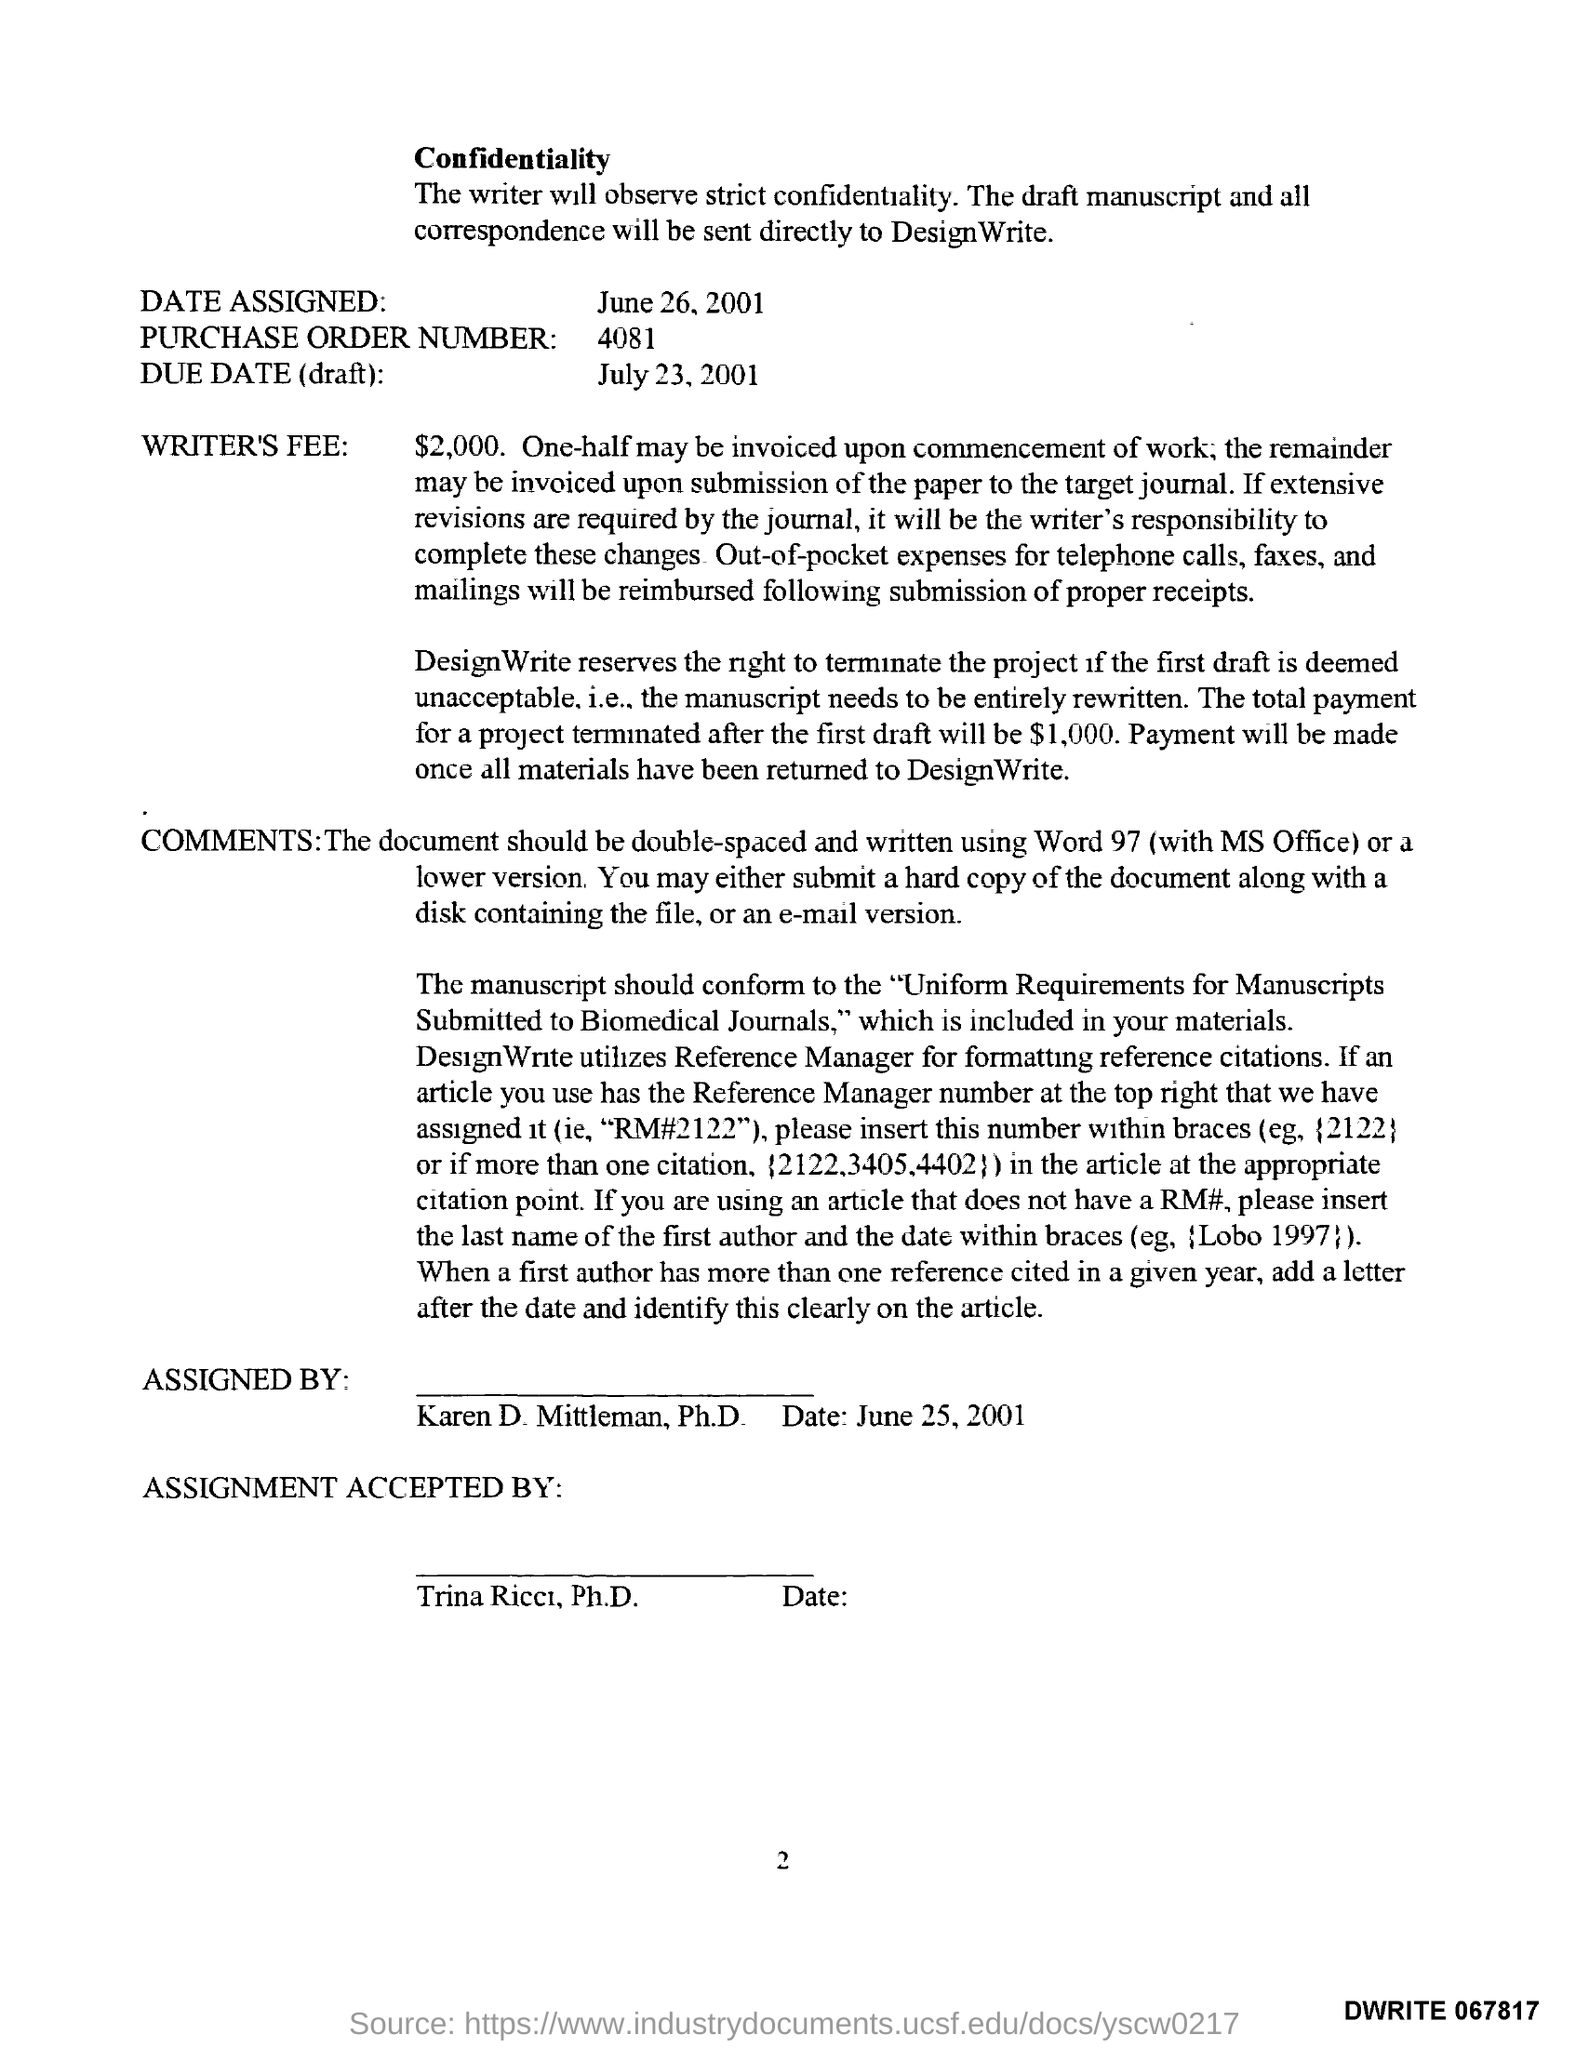Highlight a few significant elements in this photo. Trina Ricci, Ph.D., has accepted the assignment. The document has been assigned by Karen D. Mittleman, Ph.D. The date assigned as per the document is June 26, 2001. The writer's fee mentioned in the document is $2,000. The total payment for a project that is terminated after the first draft is $1,000. 